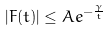<formula> <loc_0><loc_0><loc_500><loc_500>| F ( t ) | \leq A e ^ { - \frac { \gamma } { t } }</formula> 